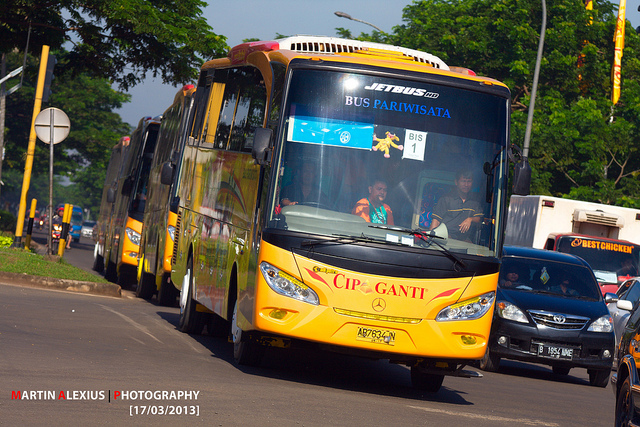Could you tell me about the setting where this image was taken? The image appears to have been taken on a busy city street, under a clear, sunny day. The surroundings are lush with greenery, indicating it might be an area with well-maintained foliage. Several yellow buses are forming a convoy, and there are other vehicles, such as a black car and a white vehicle, around them. The roads are wide and well-paved, suitable for heavy vehicles like the buses shown. What might be the purpose of these buses in the convoy? These buses labeled 'BUS PARIWISATA' suggest they are part of a tourism or sightseeing service. They might be transporting tourists or guests on a guided tour, possibly exploring various attractions in the city or surrounding areas. Given their coordinated appearance and the cleanliness of the buses, it's likely they are part of an organized tour group. 